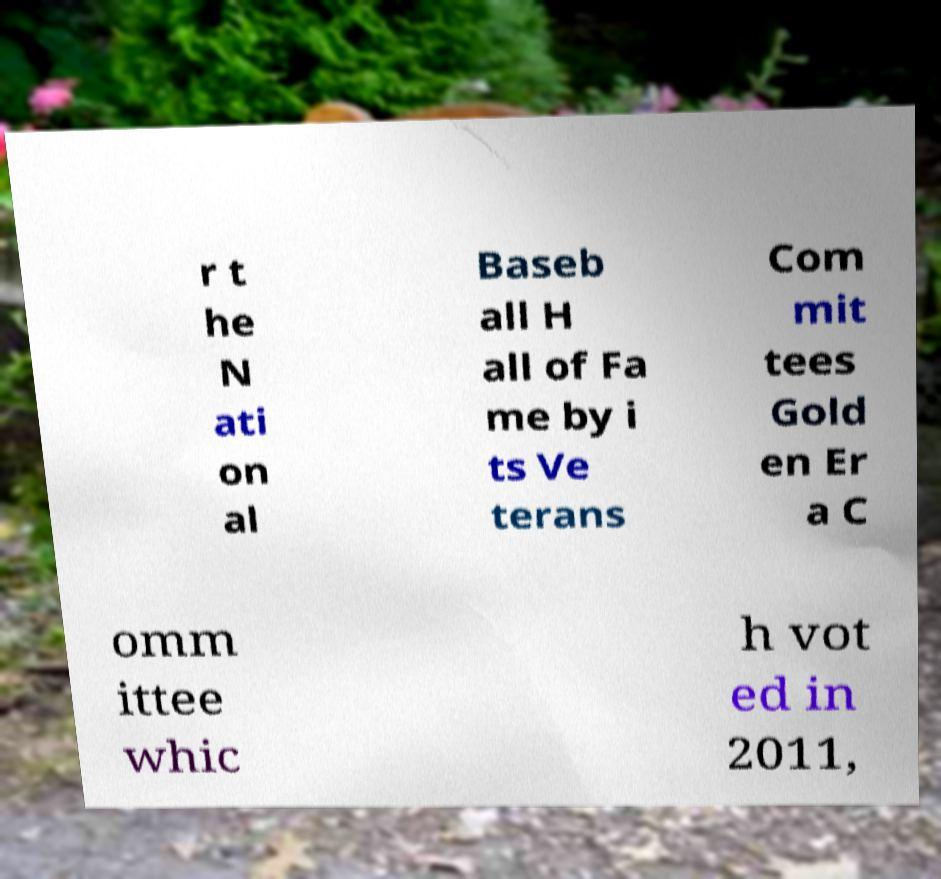Can you accurately transcribe the text from the provided image for me? r t he N ati on al Baseb all H all of Fa me by i ts Ve terans Com mit tees Gold en Er a C omm ittee whic h vot ed in 2011, 